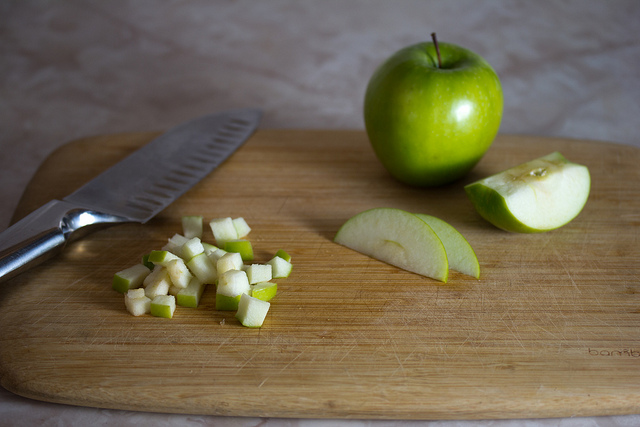What tool is typically used to cut the apples in the image? The tool visible in the image for cutting apples is a kitchen knife, which shows evidence of use with the apples. It's a fundamental utensil in fruit preparation, ideal for achieving the clean slices and dices visible on the board. 